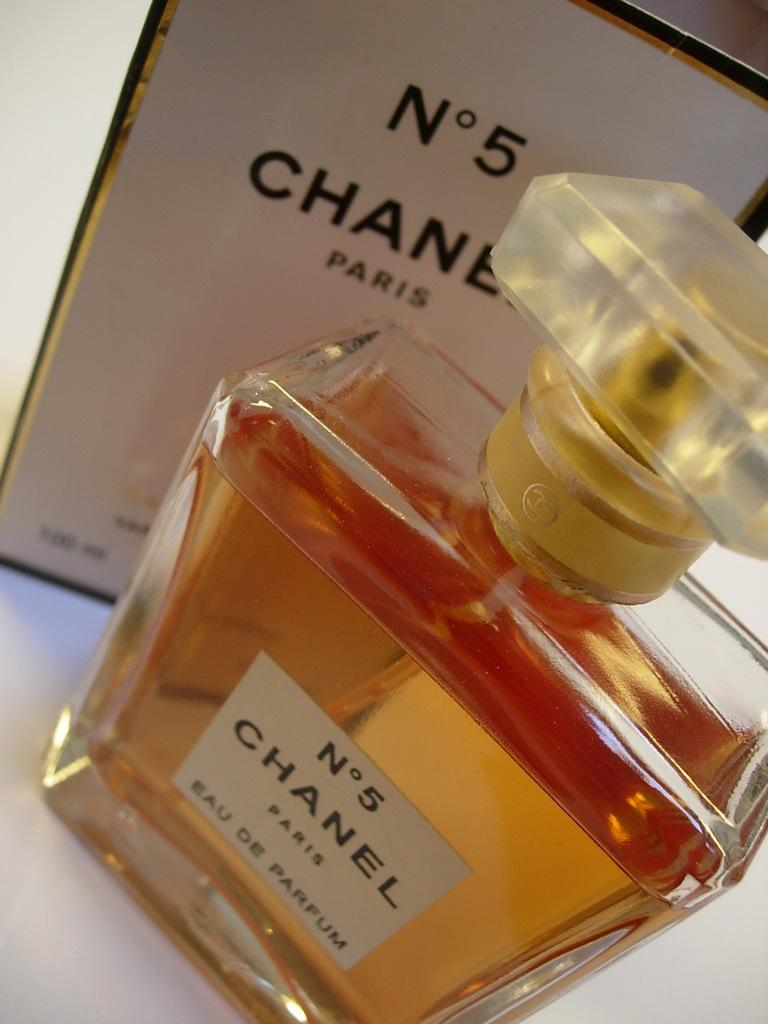<image>
Relay a brief, clear account of the picture shown. A bottle of Chanel number 5 Eau De Parfum. 